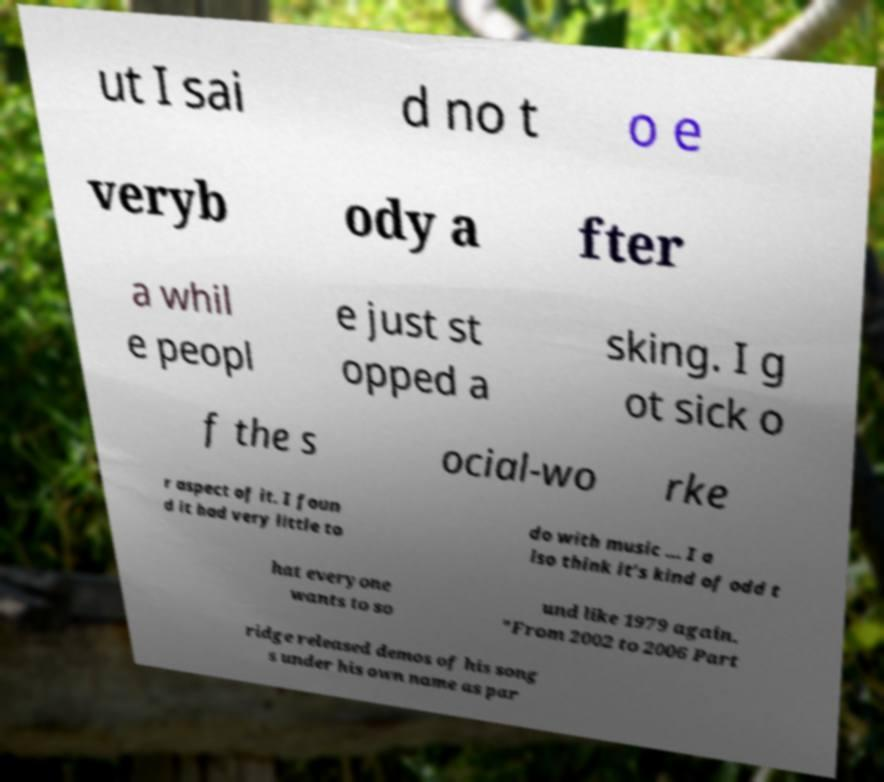I need the written content from this picture converted into text. Can you do that? ut I sai d no t o e veryb ody a fter a whil e peopl e just st opped a sking. I g ot sick o f the s ocial-wo rke r aspect of it. I foun d it had very little to do with music ... I a lso think it’s kind of odd t hat everyone wants to so und like 1979 again. "From 2002 to 2006 Part ridge released demos of his song s under his own name as par 